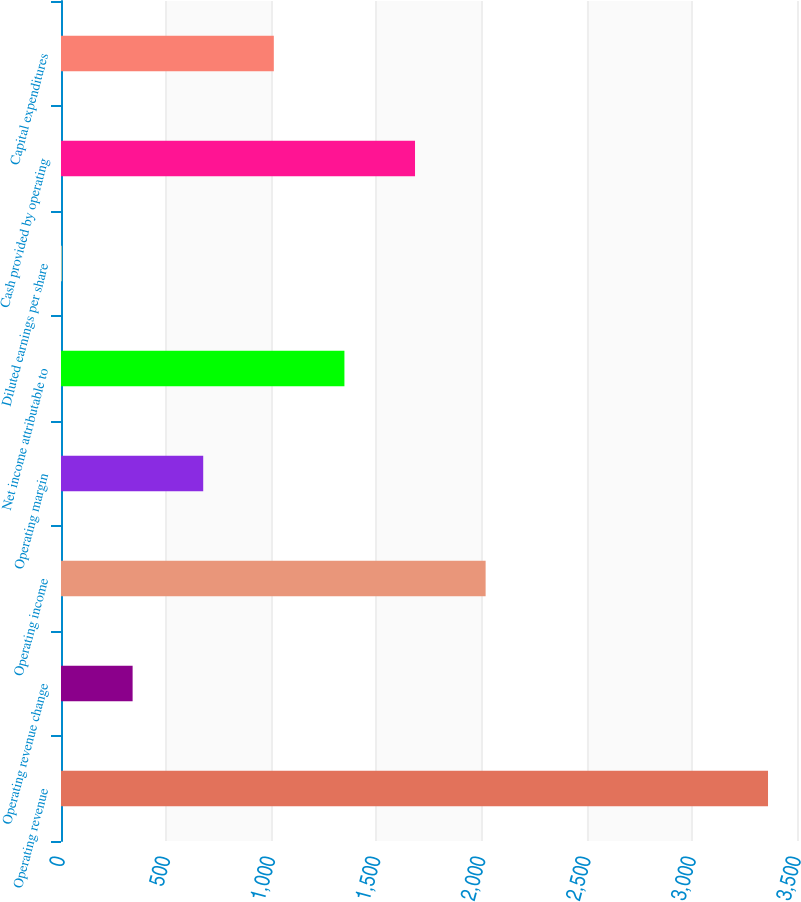Convert chart to OTSL. <chart><loc_0><loc_0><loc_500><loc_500><bar_chart><fcel>Operating revenue<fcel>Operating revenue change<fcel>Operating income<fcel>Operating margin<fcel>Net income attributable to<fcel>Diluted earnings per share<fcel>Cash provided by operating<fcel>Capital expenditures<nl><fcel>3362.2<fcel>340.57<fcel>2019.27<fcel>676.31<fcel>1347.79<fcel>4.83<fcel>1683.53<fcel>1012.05<nl></chart> 